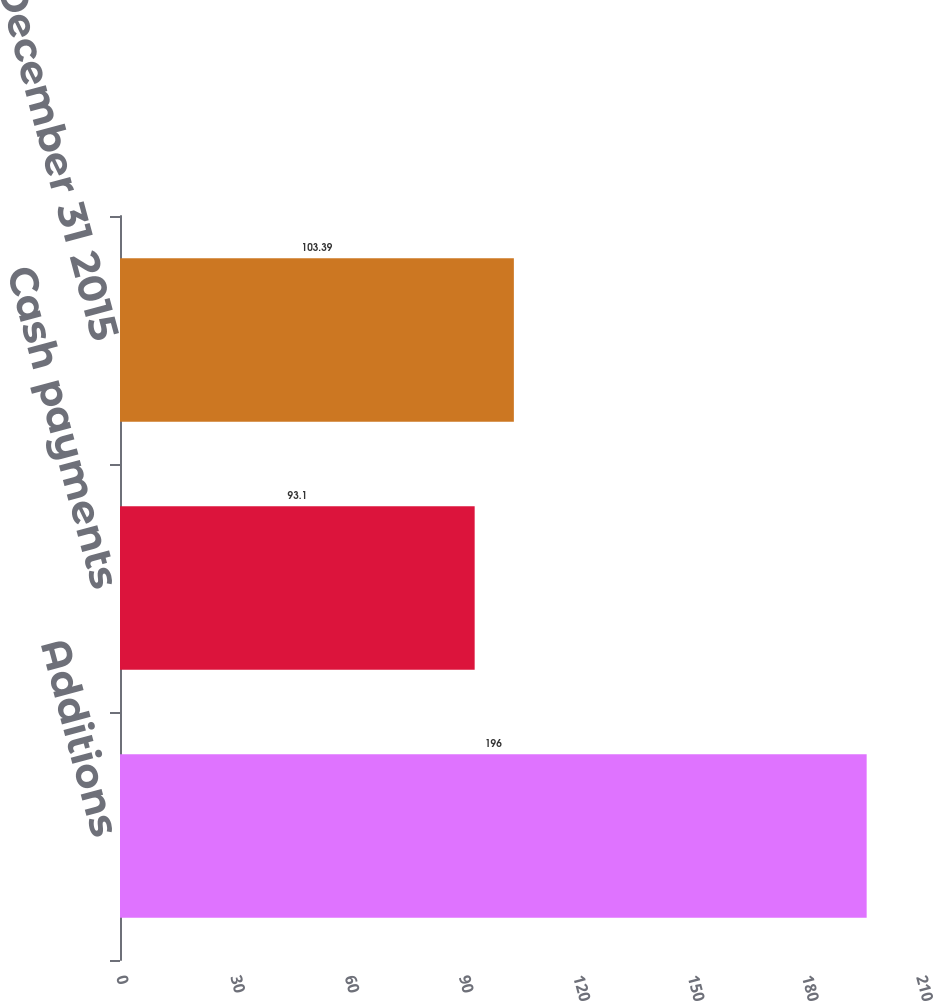<chart> <loc_0><loc_0><loc_500><loc_500><bar_chart><fcel>Additions<fcel>Cash payments<fcel>Balance December 31 2015<nl><fcel>196<fcel>93.1<fcel>103.39<nl></chart> 